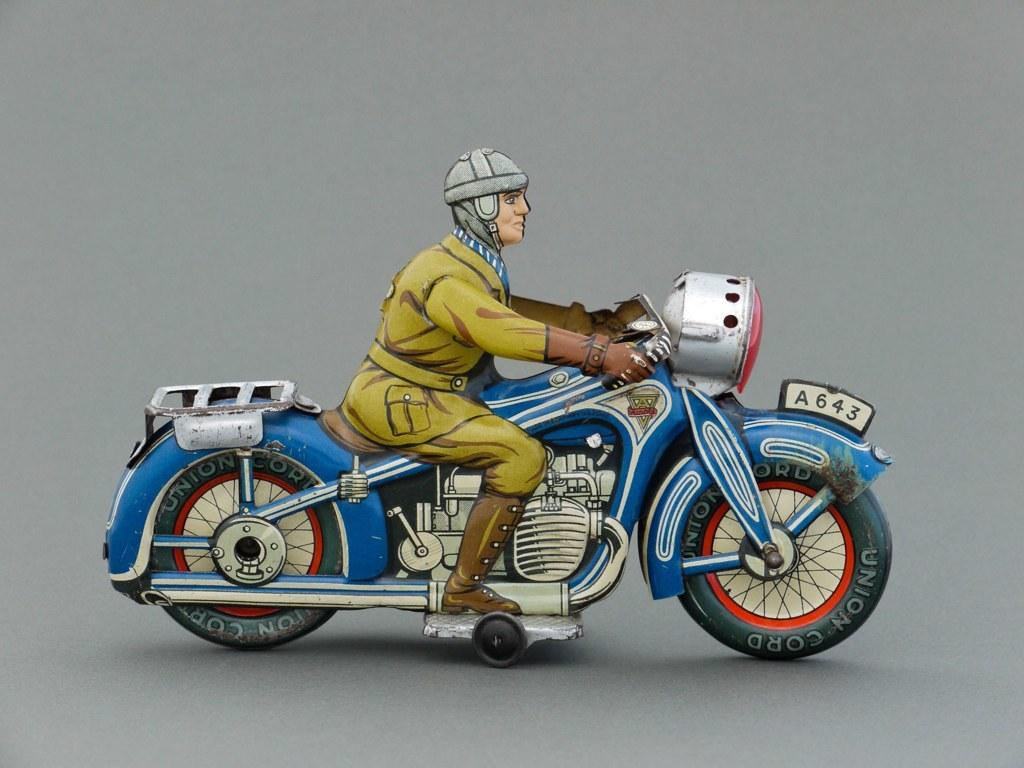What is the main object in the image? There is a toy bike in the image. Who is interacting with the toy bike? A man is sitting on the toy bike. What is the position of the toy bike and the man in the image? The toy bike and the man are on a surface. What type of pancake is being served on the coach in the image? There is no pancake or coach present in the image; it features a toy bike and a man sitting on it. What date is marked on the calendar in the image? There is no calendar present in the image. 